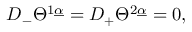<formula> <loc_0><loc_0><loc_500><loc_500>{ D } _ { - } \Theta ^ { 1 \underline { \alpha } } = { D } _ { + } \Theta ^ { 2 \underline { \alpha } } = 0 ,</formula> 